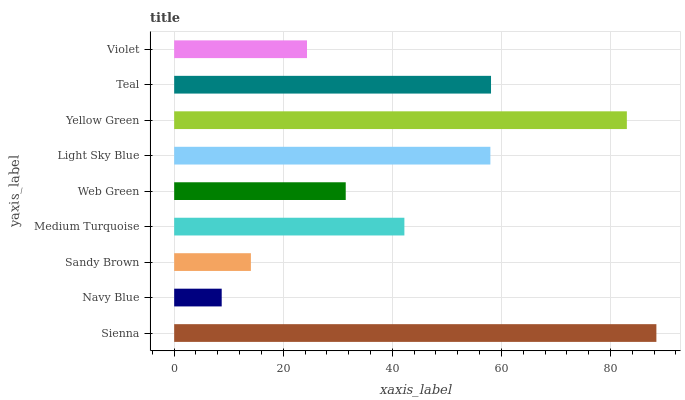Is Navy Blue the minimum?
Answer yes or no. Yes. Is Sienna the maximum?
Answer yes or no. Yes. Is Sandy Brown the minimum?
Answer yes or no. No. Is Sandy Brown the maximum?
Answer yes or no. No. Is Sandy Brown greater than Navy Blue?
Answer yes or no. Yes. Is Navy Blue less than Sandy Brown?
Answer yes or no. Yes. Is Navy Blue greater than Sandy Brown?
Answer yes or no. No. Is Sandy Brown less than Navy Blue?
Answer yes or no. No. Is Medium Turquoise the high median?
Answer yes or no. Yes. Is Medium Turquoise the low median?
Answer yes or no. Yes. Is Yellow Green the high median?
Answer yes or no. No. Is Violet the low median?
Answer yes or no. No. 